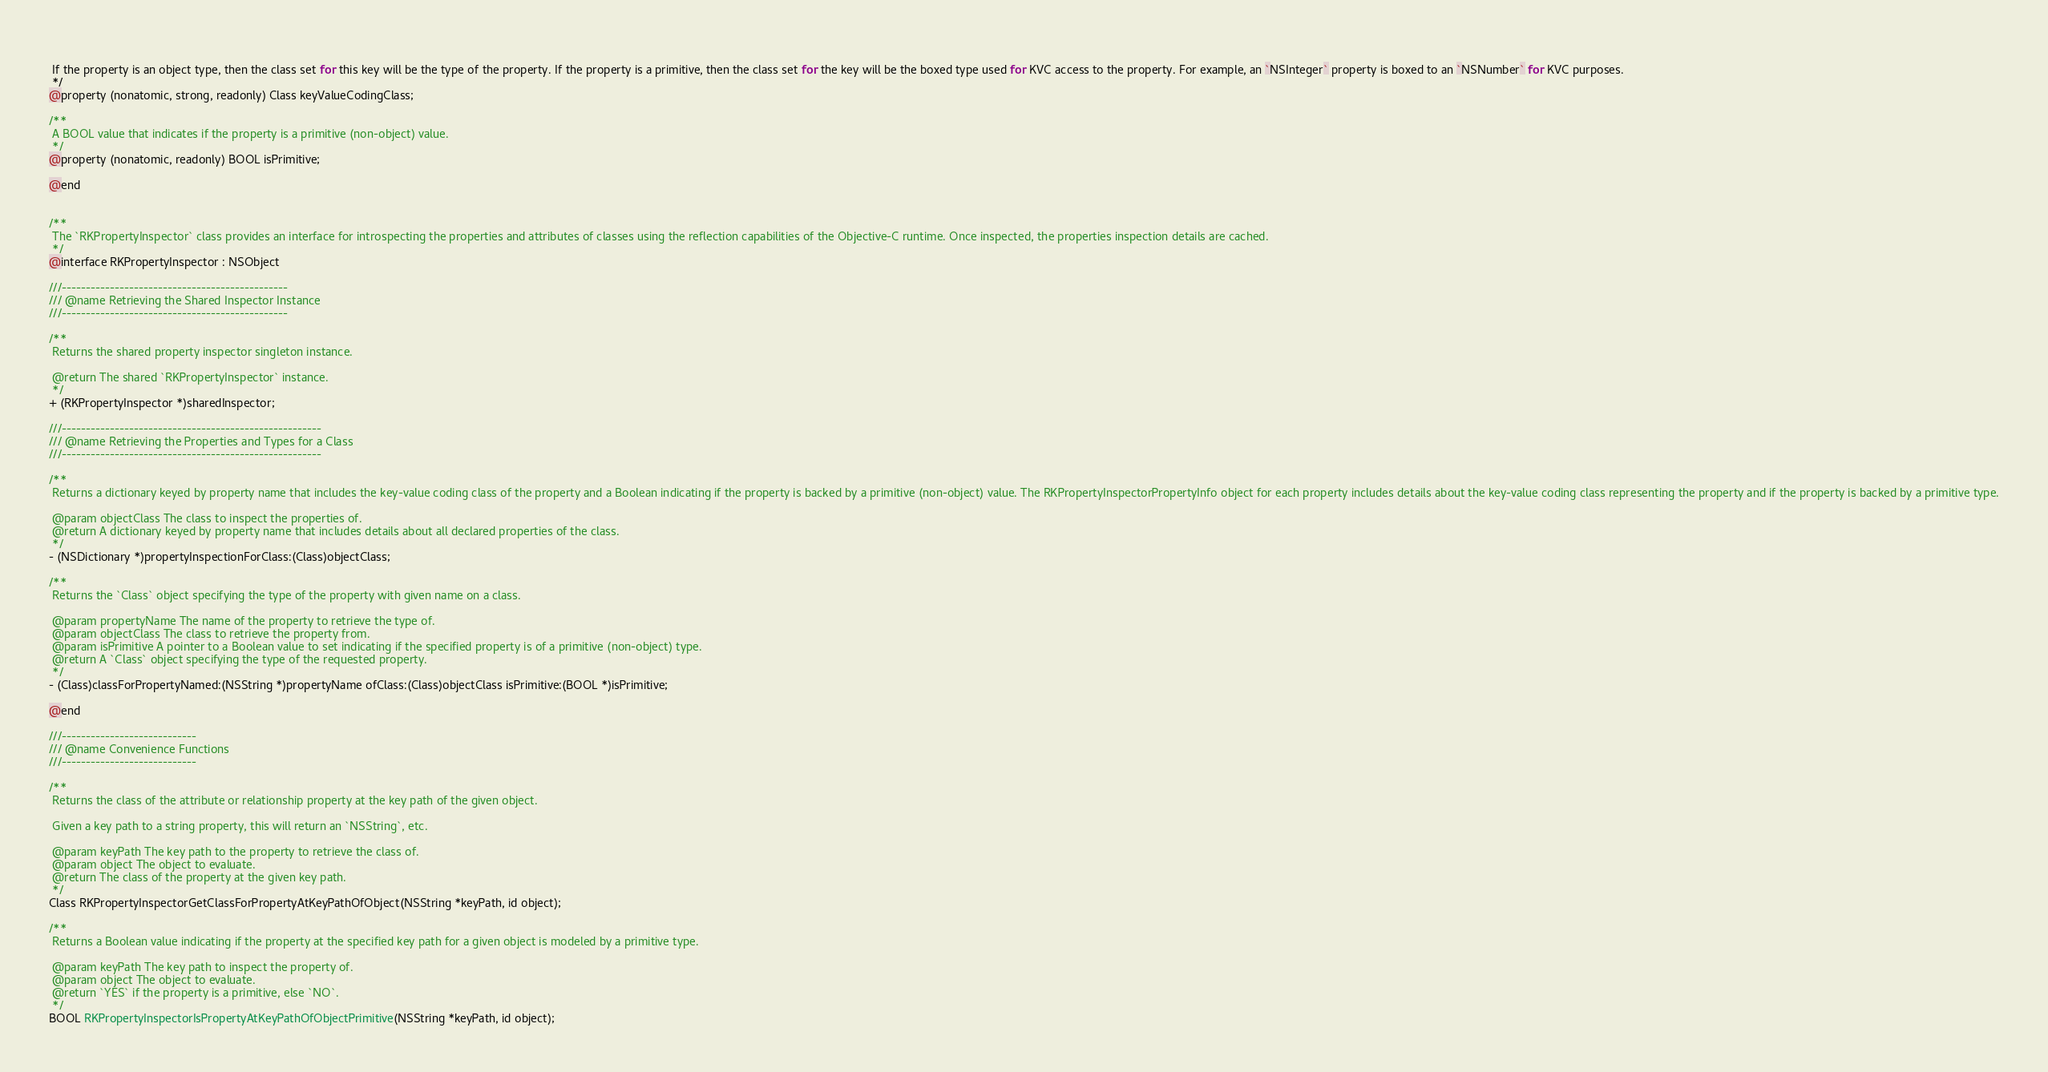Convert code to text. <code><loc_0><loc_0><loc_500><loc_500><_C_> 
 If the property is an object type, then the class set for this key will be the type of the property. If the property is a primitive, then the class set for the key will be the boxed type used for KVC access to the property. For example, an `NSInteger` property is boxed to an `NSNumber` for KVC purposes.
 */
@property (nonatomic, strong, readonly) Class keyValueCodingClass;

/**
 A BOOL value that indicates if the property is a primitive (non-object) value.
 */
@property (nonatomic, readonly) BOOL isPrimitive;

@end


/**
 The `RKPropertyInspector` class provides an interface for introspecting the properties and attributes of classes using the reflection capabilities of the Objective-C runtime. Once inspected, the properties inspection details are cached.
 */
@interface RKPropertyInspector : NSObject

///-----------------------------------------------
/// @name Retrieving the Shared Inspector Instance
///-----------------------------------------------

/**
 Returns the shared property inspector singleton instance.

 @return The shared `RKPropertyInspector` instance.
 */
+ (RKPropertyInspector *)sharedInspector;

///------------------------------------------------------
/// @name Retrieving the Properties and Types for a Class
///------------------------------------------------------

/**
 Returns a dictionary keyed by property name that includes the key-value coding class of the property and a Boolean indicating if the property is backed by a primitive (non-object) value. The RKPropertyInspectorPropertyInfo object for each property includes details about the key-value coding class representing the property and if the property is backed by a primitive type.
 
 @param objectClass The class to inspect the properties of.
 @return A dictionary keyed by property name that includes details about all declared properties of the class.
 */
- (NSDictionary *)propertyInspectionForClass:(Class)objectClass;

/**
 Returns the `Class` object specifying the type of the property with given name on a class.

 @param propertyName The name of the property to retrieve the type of.
 @param objectClass The class to retrieve the property from.
 @param isPrimitive A pointer to a Boolean value to set indicating if the specified property is of a primitive (non-object) type.
 @return A `Class` object specifying the type of the requested property.
 */
- (Class)classForPropertyNamed:(NSString *)propertyName ofClass:(Class)objectClass isPrimitive:(BOOL *)isPrimitive;

@end

///----------------------------
/// @name Convenience Functions
///----------------------------

/**
 Returns the class of the attribute or relationship property at the key path of the given object.
 
 Given a key path to a string property, this will return an `NSString`, etc.
 
 @param keyPath The key path to the property to retrieve the class of.
 @param object The object to evaluate.
 @return The class of the property at the given key path.
 */
Class RKPropertyInspectorGetClassForPropertyAtKeyPathOfObject(NSString *keyPath, id object);

/**
 Returns a Boolean value indicating if the property at the specified key path for a given object is modeled by a primitive type.
 
 @param keyPath The key path to inspect the property of.
 @param object The object to evaluate.
 @return `YES` if the property is a primitive, else `NO`.
 */
BOOL RKPropertyInspectorIsPropertyAtKeyPathOfObjectPrimitive(NSString *keyPath, id object);
</code> 